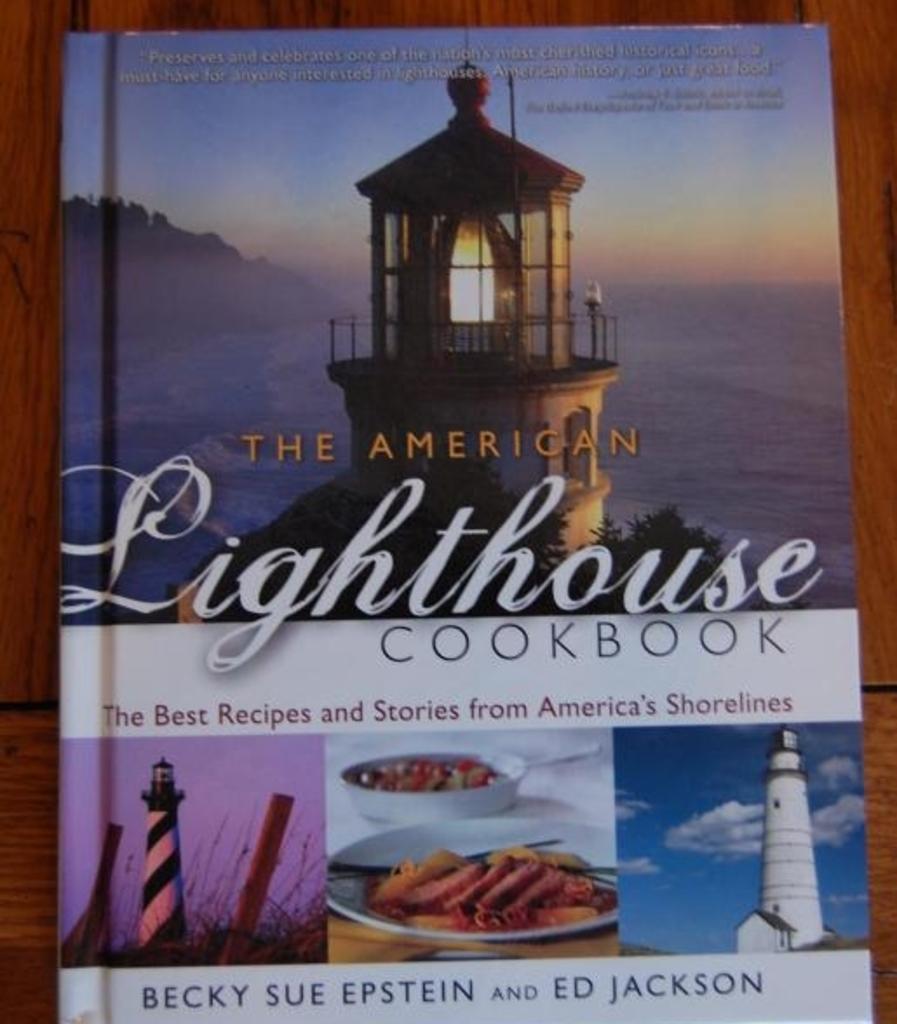What is the book about?
Provide a short and direct response. The best recipes and stories from america's shorelines. Who are the authors of this book?
Your response must be concise. Becky sue epstein and ed jackson. 